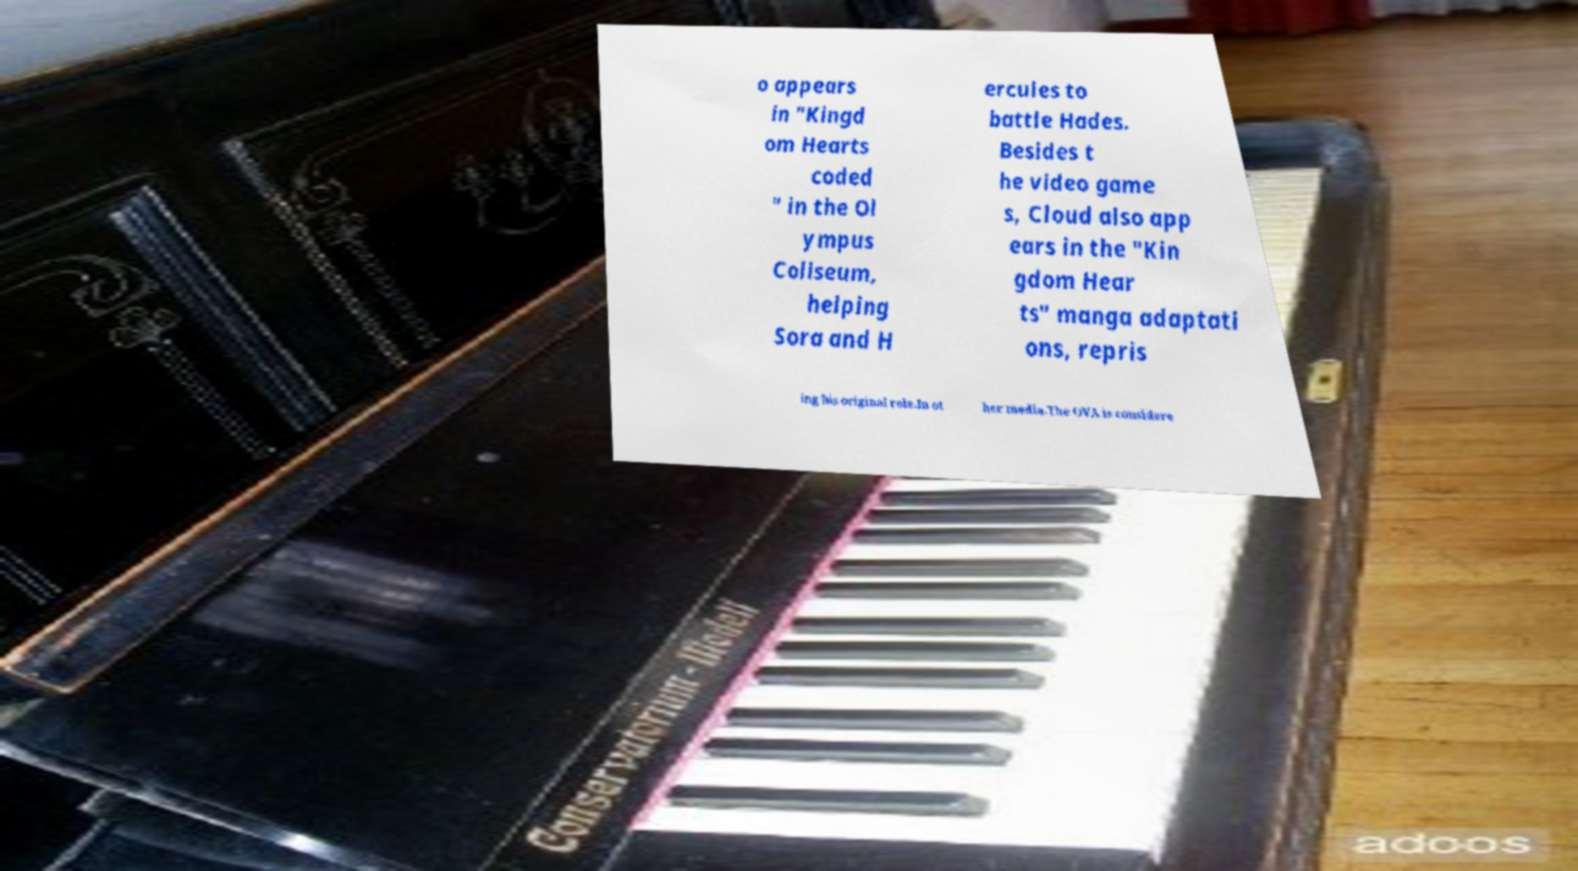There's text embedded in this image that I need extracted. Can you transcribe it verbatim? o appears in "Kingd om Hearts coded " in the Ol ympus Coliseum, helping Sora and H ercules to battle Hades. Besides t he video game s, Cloud also app ears in the "Kin gdom Hear ts" manga adaptati ons, repris ing his original role.In ot her media.The OVA is considere 